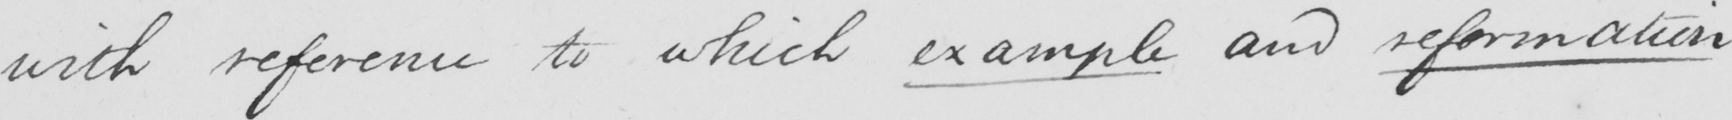Can you tell me what this handwritten text says? with reference to which example and reformation 